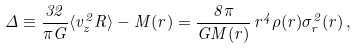<formula> <loc_0><loc_0><loc_500><loc_500>\Delta \equiv \frac { 3 2 } { \pi G } \langle v ^ { 2 } _ { z } R \rangle - M ( r ) = \frac { 8 \pi } { G M ( r ) } \, r ^ { 4 } \rho ( r ) \sigma _ { r } ^ { 2 } ( r ) \, ,</formula> 